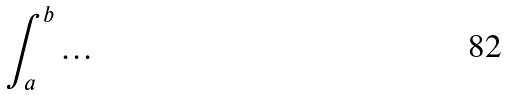Convert formula to latex. <formula><loc_0><loc_0><loc_500><loc_500>\int _ { a } ^ { b } \dots</formula> 